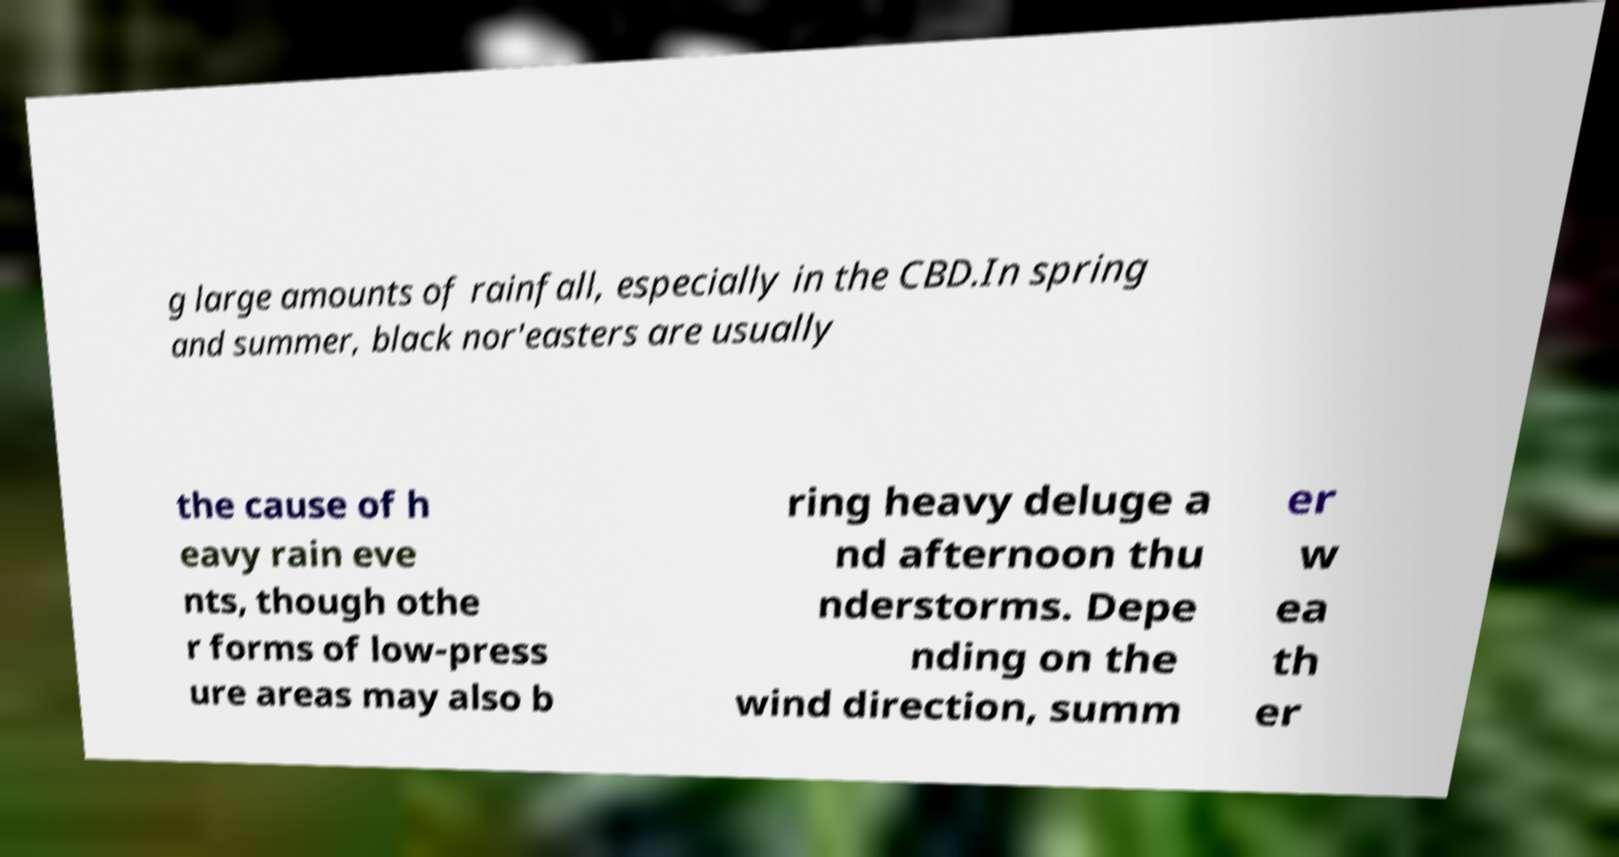There's text embedded in this image that I need extracted. Can you transcribe it verbatim? g large amounts of rainfall, especially in the CBD.In spring and summer, black nor'easters are usually the cause of h eavy rain eve nts, though othe r forms of low-press ure areas may also b ring heavy deluge a nd afternoon thu nderstorms. Depe nding on the wind direction, summ er w ea th er 